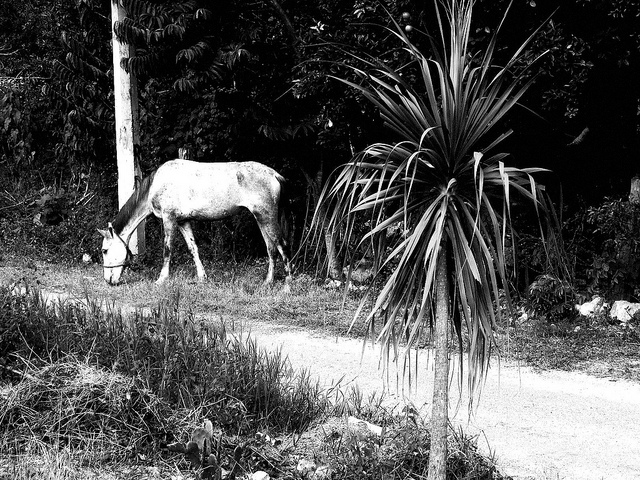How does the black and white filter alter the mood of the image? The black and white filter gives the image a timeless quality, highlighting textures and contrast over colors and may evoke a sense of nostalgia or focus more on the shapes and composition of the scene. 